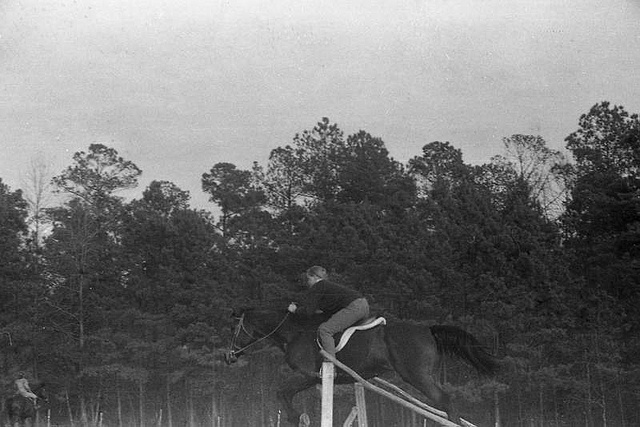Describe the objects in this image and their specific colors. I can see horse in lightgray, black, gray, and darkgray tones, people in lightgray, black, gray, and darkgray tones, horse in gray, black, and lightgray tones, people in gray, black, and lightgray tones, and horse in gray, black, and lightgray tones in this image. 